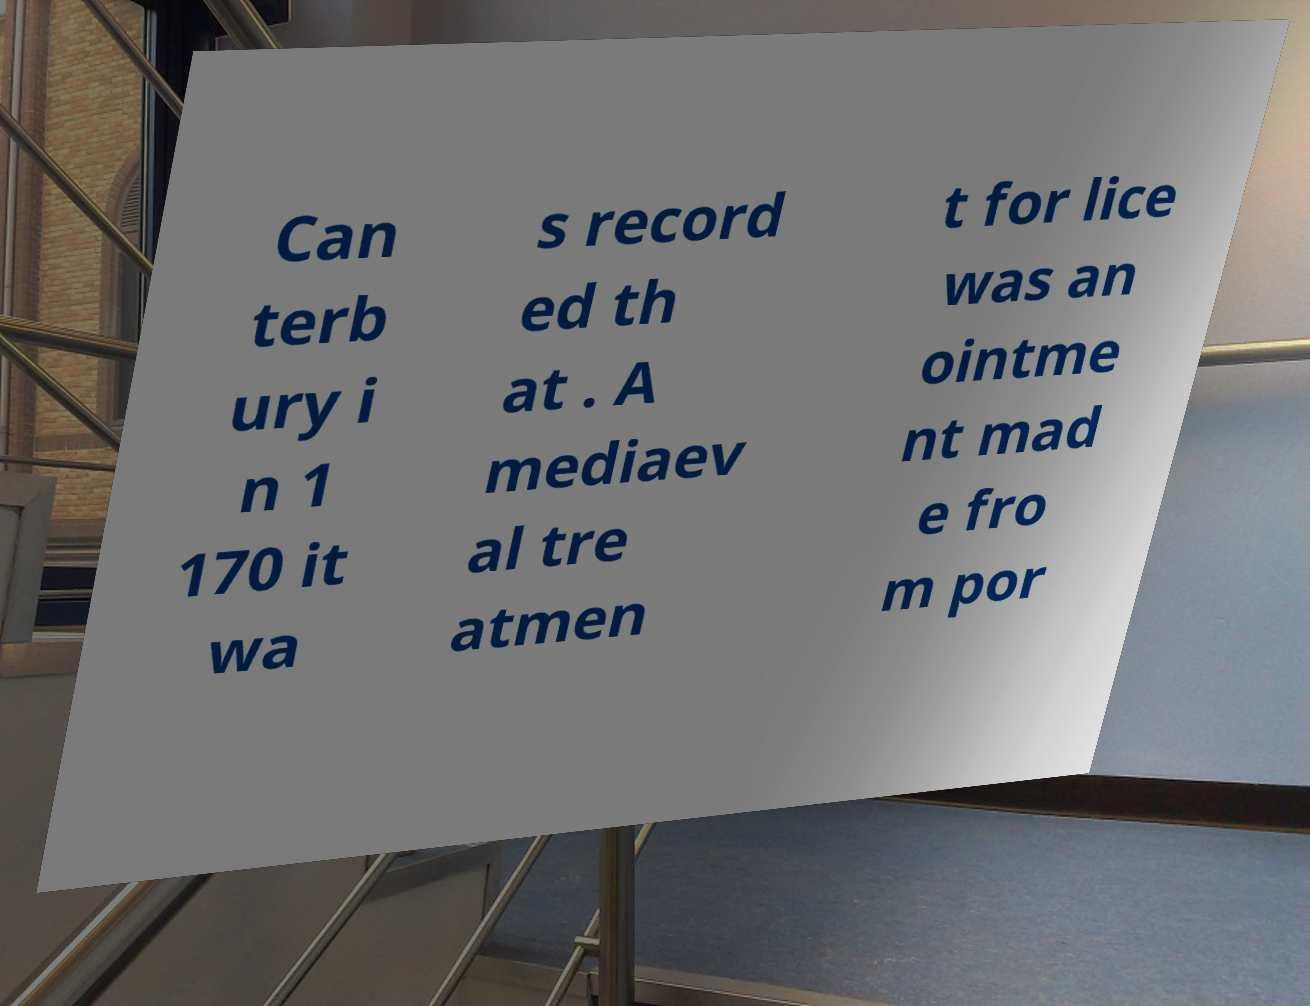I need the written content from this picture converted into text. Can you do that? Can terb ury i n 1 170 it wa s record ed th at . A mediaev al tre atmen t for lice was an ointme nt mad e fro m por 